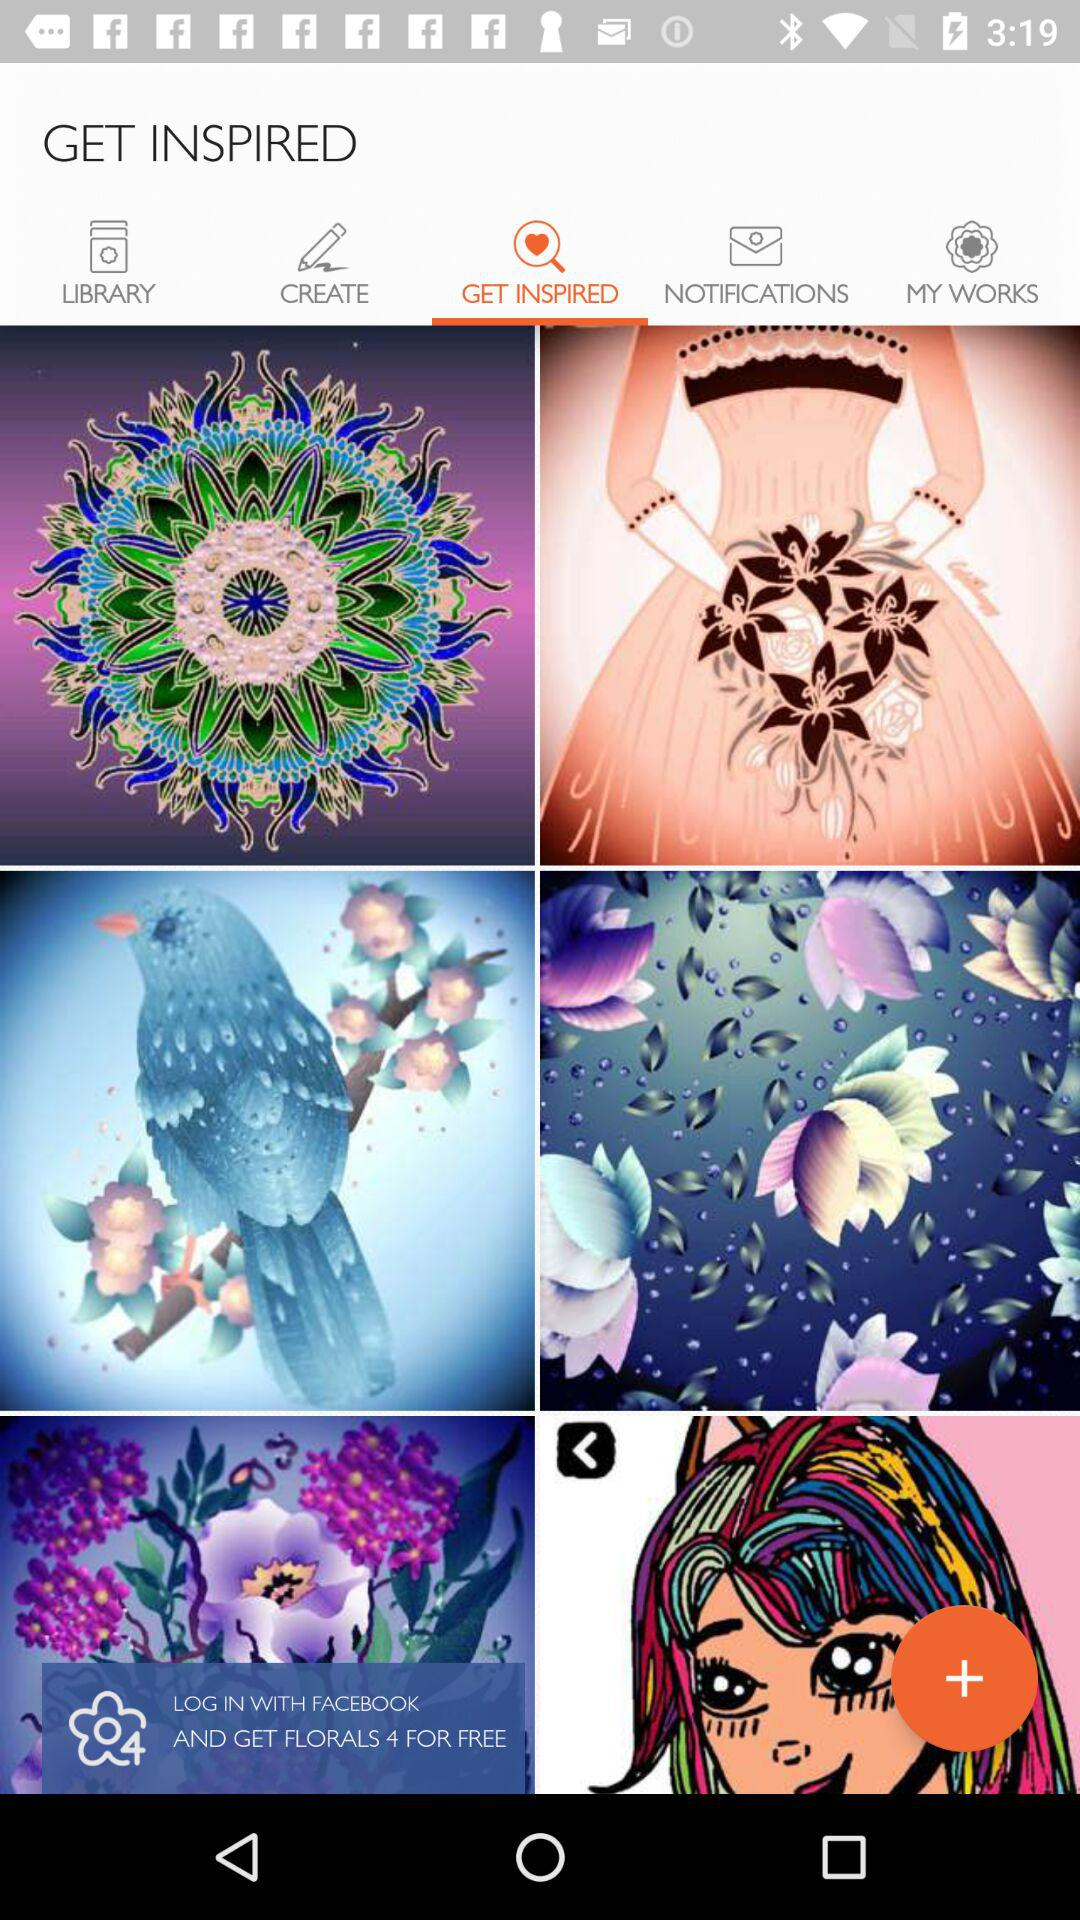Which images are saved in "LIBRARY"?
When the provided information is insufficient, respond with <no answer>. <no answer> 